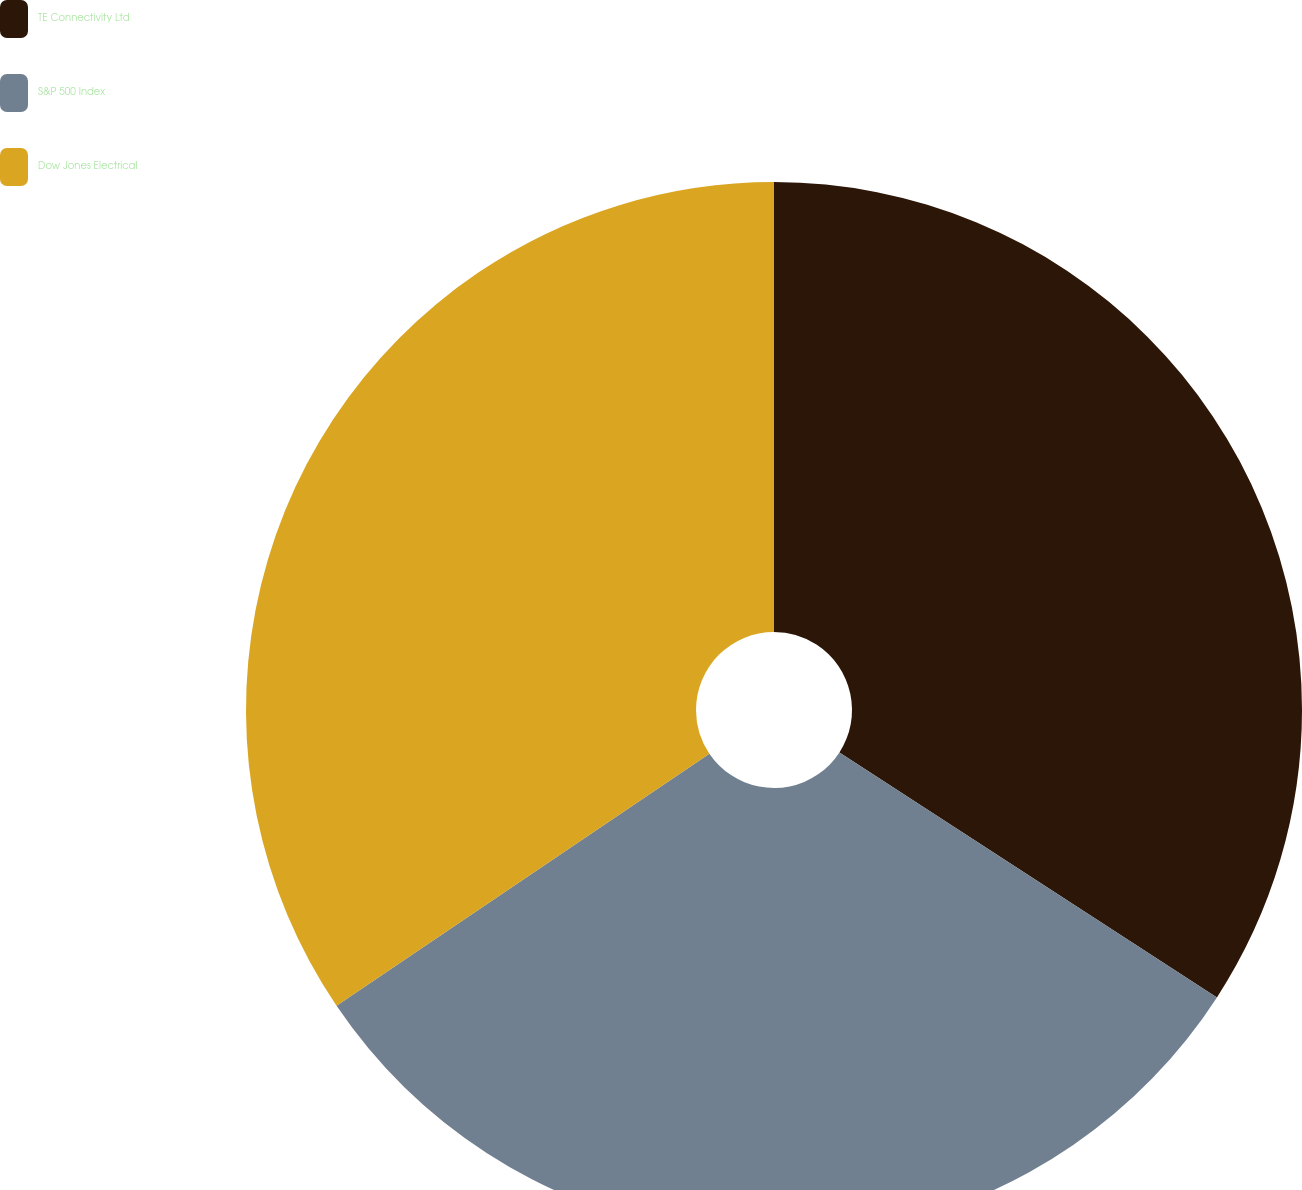Convert chart to OTSL. <chart><loc_0><loc_0><loc_500><loc_500><pie_chart><fcel>TE Connectivity Ltd<fcel>S&P 500 Index<fcel>Dow Jones Electrical<nl><fcel>34.16%<fcel>31.38%<fcel>34.46%<nl></chart> 